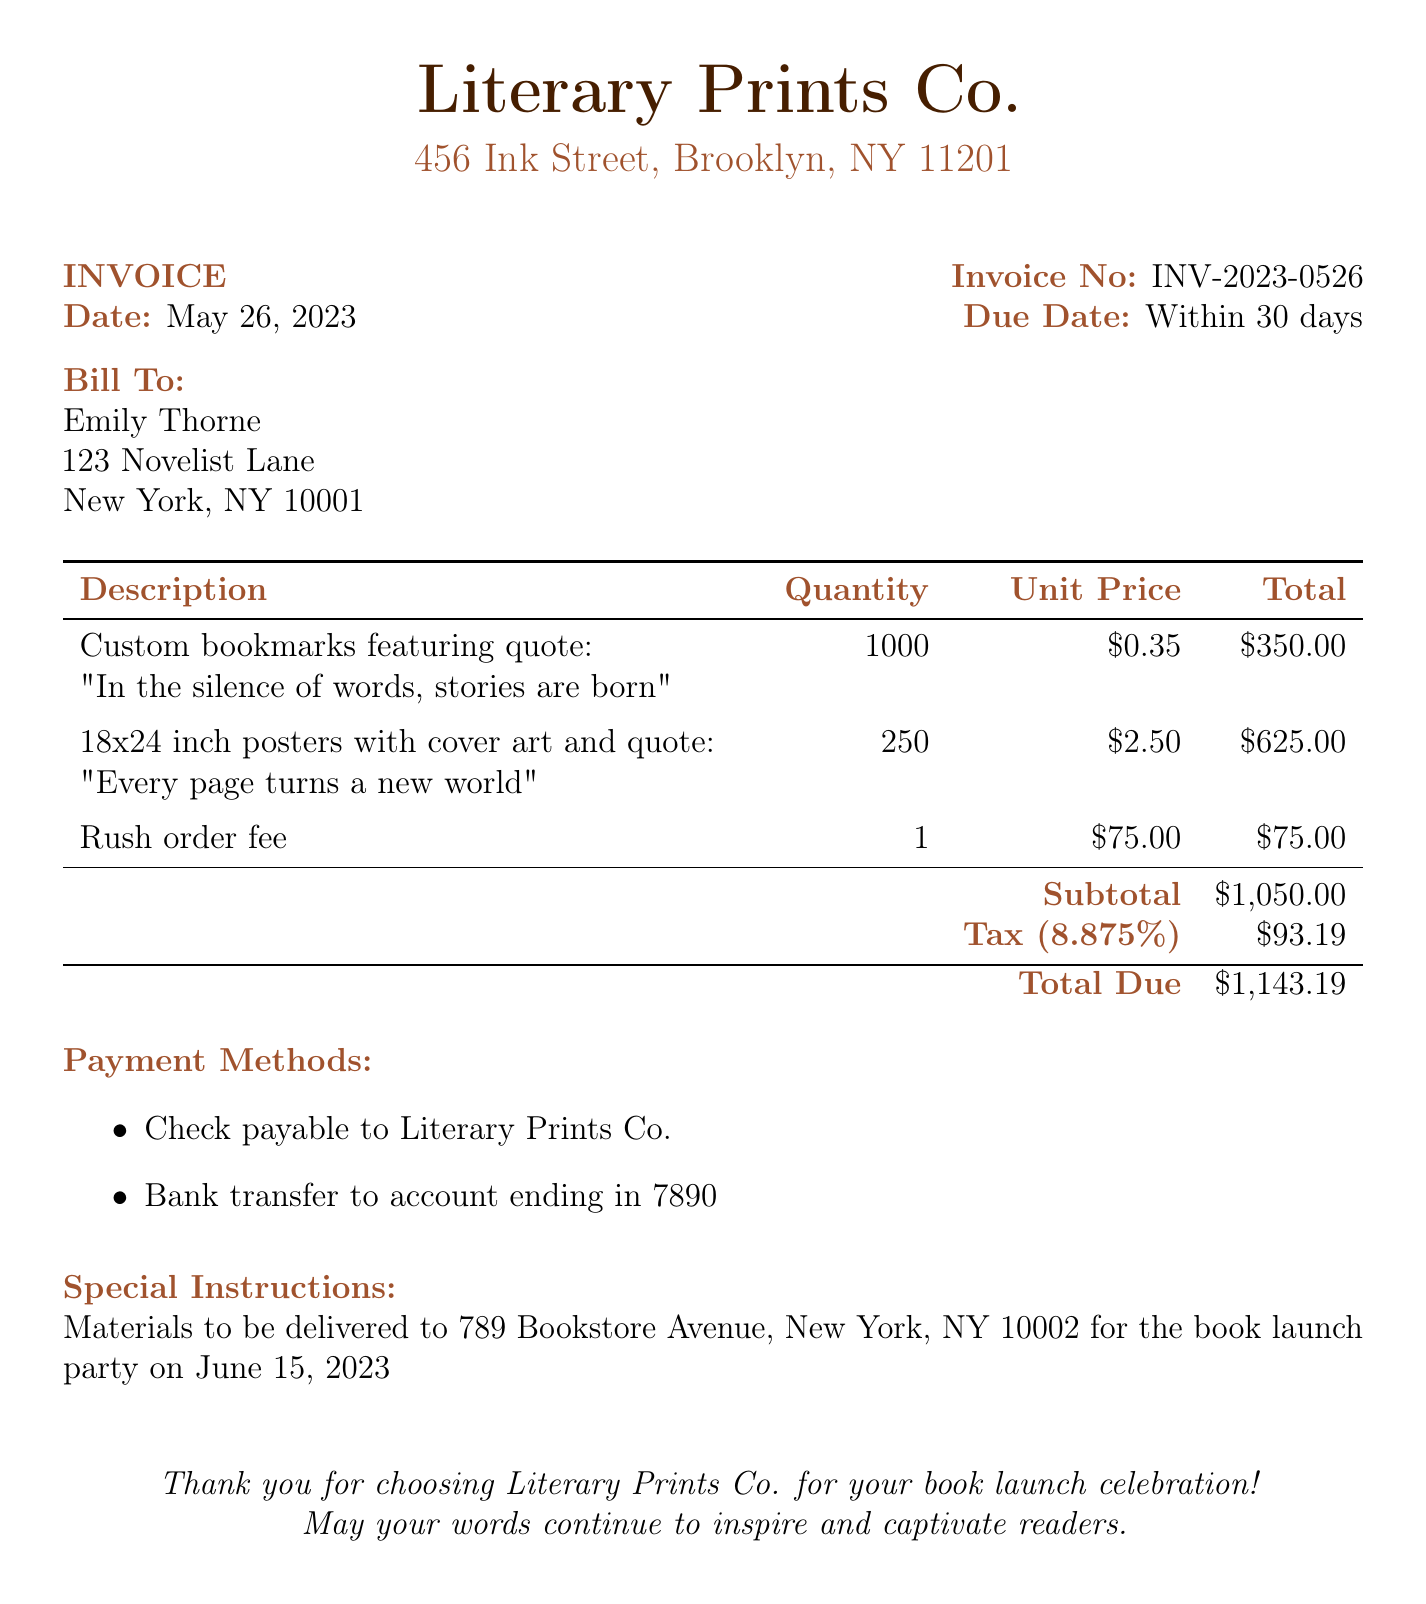What is the invoice number? The invoice number is specified under the header "Invoice No" in the document.
Answer: INV-2023-0526 What is the due date for the invoice? The due date is mentioned in the document as "Due Date," which specifies when payment is expected.
Answer: Within 30 days Who is the bill addressed to? The "Bill To" section contains the name of the person receiving the invoice.
Answer: Emily Thorne What is the subtotal before tax? The subtotal is provided in the billing details before tax is added.
Answer: $1,050.00 How many posters were ordered? The quantity of posters can be found in the "Description" table for the line related to posters.
Answer: 250 What is the total due amount? The total due is explicitly mentioned at the bottom of the invoice.
Answer: $1,143.19 What is included in the special instructions? The special instructions section specifies where materials are to be delivered.
Answer: Materials to be delivered to 789 Bookstore Avenue, New York, NY 10002 What is the tax rate applied in the invoice? The tax rate is provided in the "Tax" section of the invoice, indicating the percentage added.
Answer: 8.875% What is the payment method listed? Payment methods are outlined in the document as options for settling the invoice.
Answer: Check payable to Literary Prints Co What is the total quantity of bookmarks ordered? The quantity of bookmarks is stated in the "Description" table under bookmarks.
Answer: 1000 